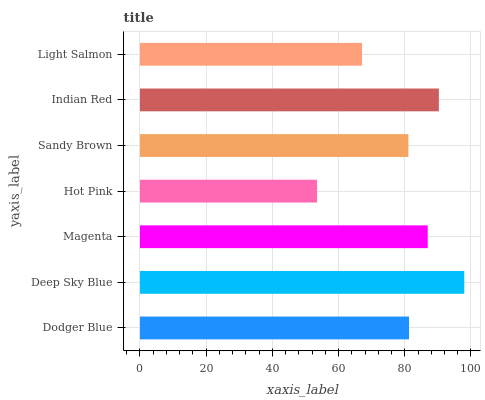Is Hot Pink the minimum?
Answer yes or no. Yes. Is Deep Sky Blue the maximum?
Answer yes or no. Yes. Is Magenta the minimum?
Answer yes or no. No. Is Magenta the maximum?
Answer yes or no. No. Is Deep Sky Blue greater than Magenta?
Answer yes or no. Yes. Is Magenta less than Deep Sky Blue?
Answer yes or no. Yes. Is Magenta greater than Deep Sky Blue?
Answer yes or no. No. Is Deep Sky Blue less than Magenta?
Answer yes or no. No. Is Dodger Blue the high median?
Answer yes or no. Yes. Is Dodger Blue the low median?
Answer yes or no. Yes. Is Deep Sky Blue the high median?
Answer yes or no. No. Is Light Salmon the low median?
Answer yes or no. No. 